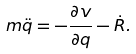Convert formula to latex. <formula><loc_0><loc_0><loc_500><loc_500>m \ddot { q } = - \frac { \partial v } { \partial q } - \dot { R } .</formula> 